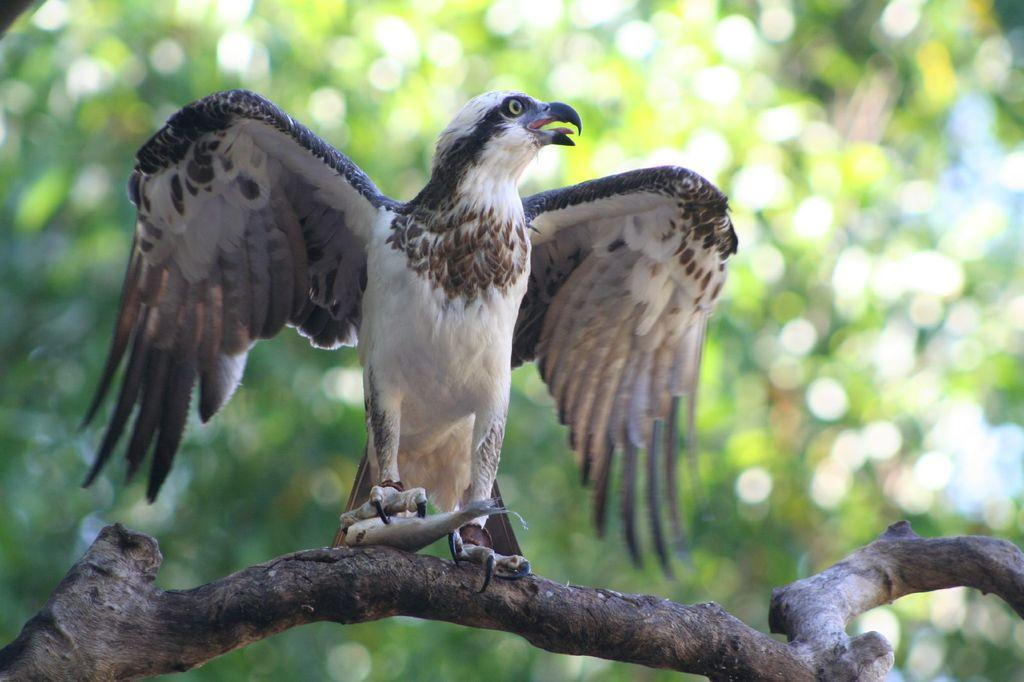What animal can be seen in the image? There is a bird in the image. Where is the bird located? The bird is sitting on a tree branch. What is the bird holding? The bird is holding a fish. What can be seen in the background of the image? There are trees in the background of the image. When was the image taken? The image was taken during the day. What type of robin is the bird in the image? The image does not specify the type of bird, so it cannot be determined if it is a robin or not. What role does the bird play in the image as a representative of a larger group? The image does not suggest any representative role for the bird; it is simply a bird sitting on a tree branch holding a fish. 